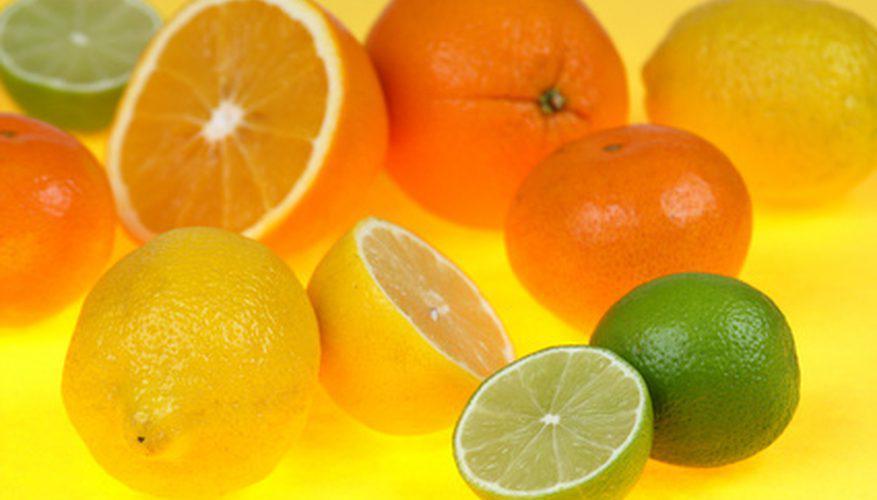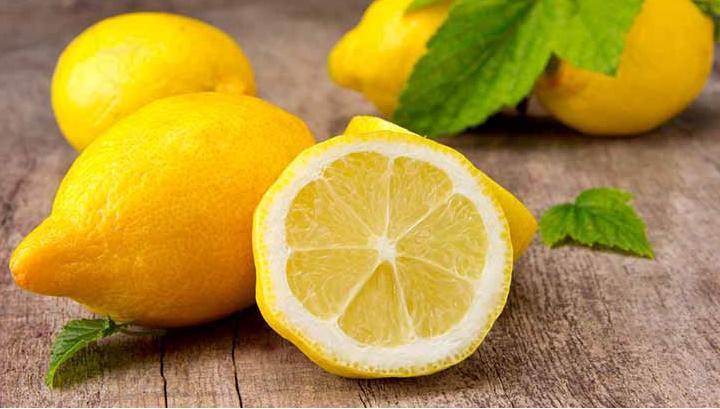The first image is the image on the left, the second image is the image on the right. Analyze the images presented: Is the assertion "The left image includes a variety of whole citrus fruits, along with at least one cut fruit and green leaves." valid? Answer yes or no. No. 